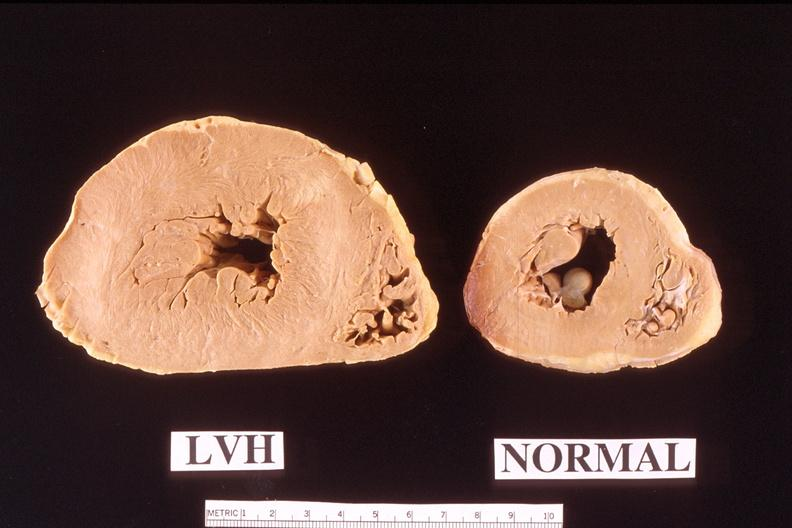does this image show heart?
Answer the question using a single word or phrase. Yes 